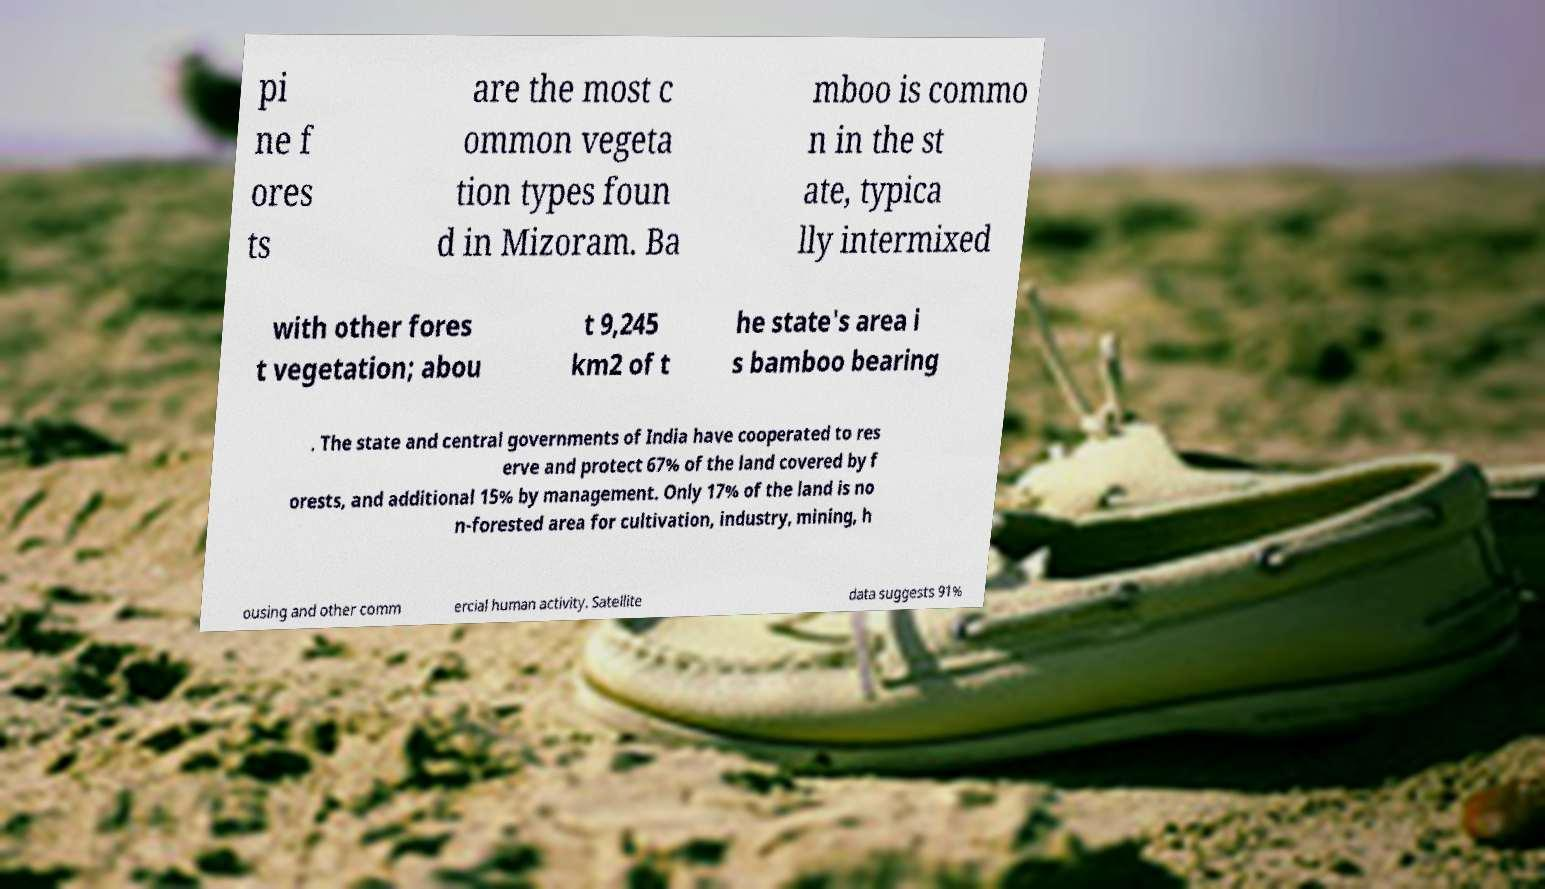I need the written content from this picture converted into text. Can you do that? pi ne f ores ts are the most c ommon vegeta tion types foun d in Mizoram. Ba mboo is commo n in the st ate, typica lly intermixed with other fores t vegetation; abou t 9,245 km2 of t he state's area i s bamboo bearing . The state and central governments of India have cooperated to res erve and protect 67% of the land covered by f orests, and additional 15% by management. Only 17% of the land is no n-forested area for cultivation, industry, mining, h ousing and other comm ercial human activity. Satellite data suggests 91% 